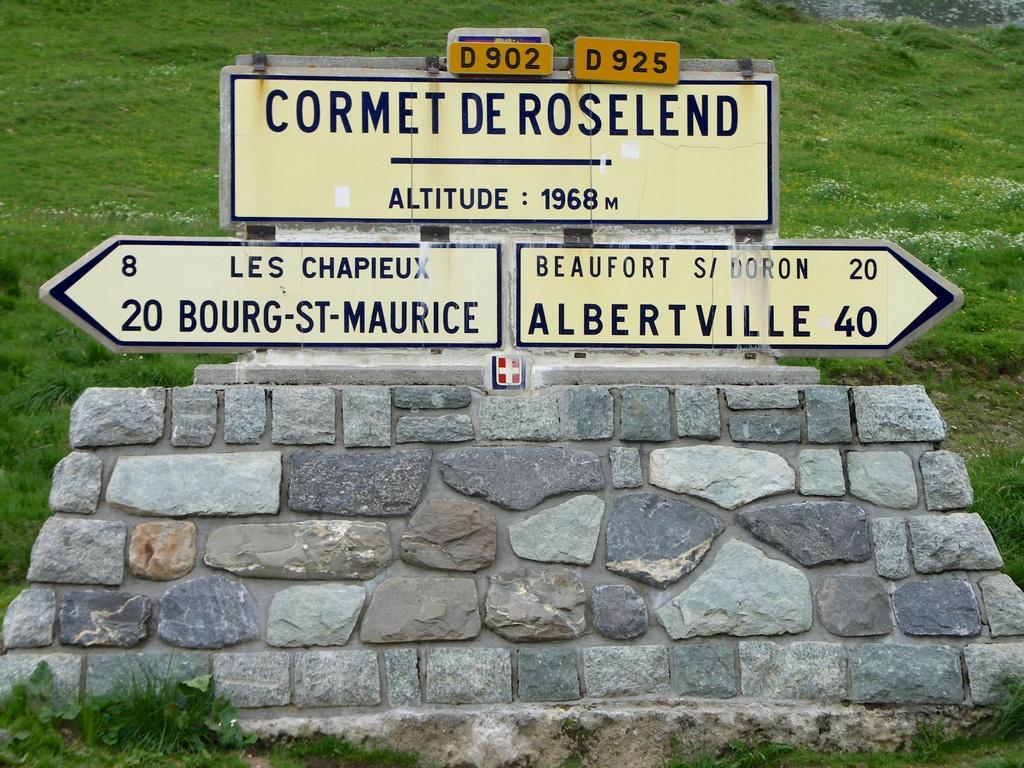<image>
Relay a brief, clear account of the picture shown. French rural signs for Cormet De Roselend on a stone structure 